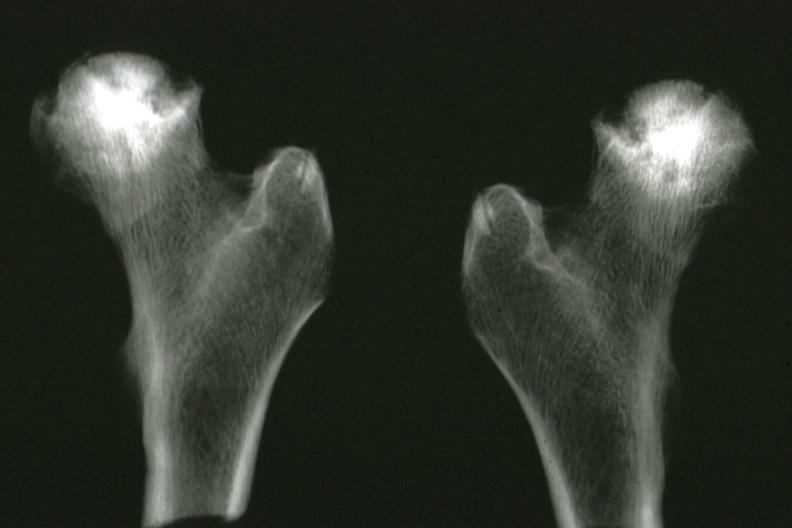what is x-ray of femoral heads removed?
Answer the question using a single word or phrase. Heads removed at autopsy good illustration 